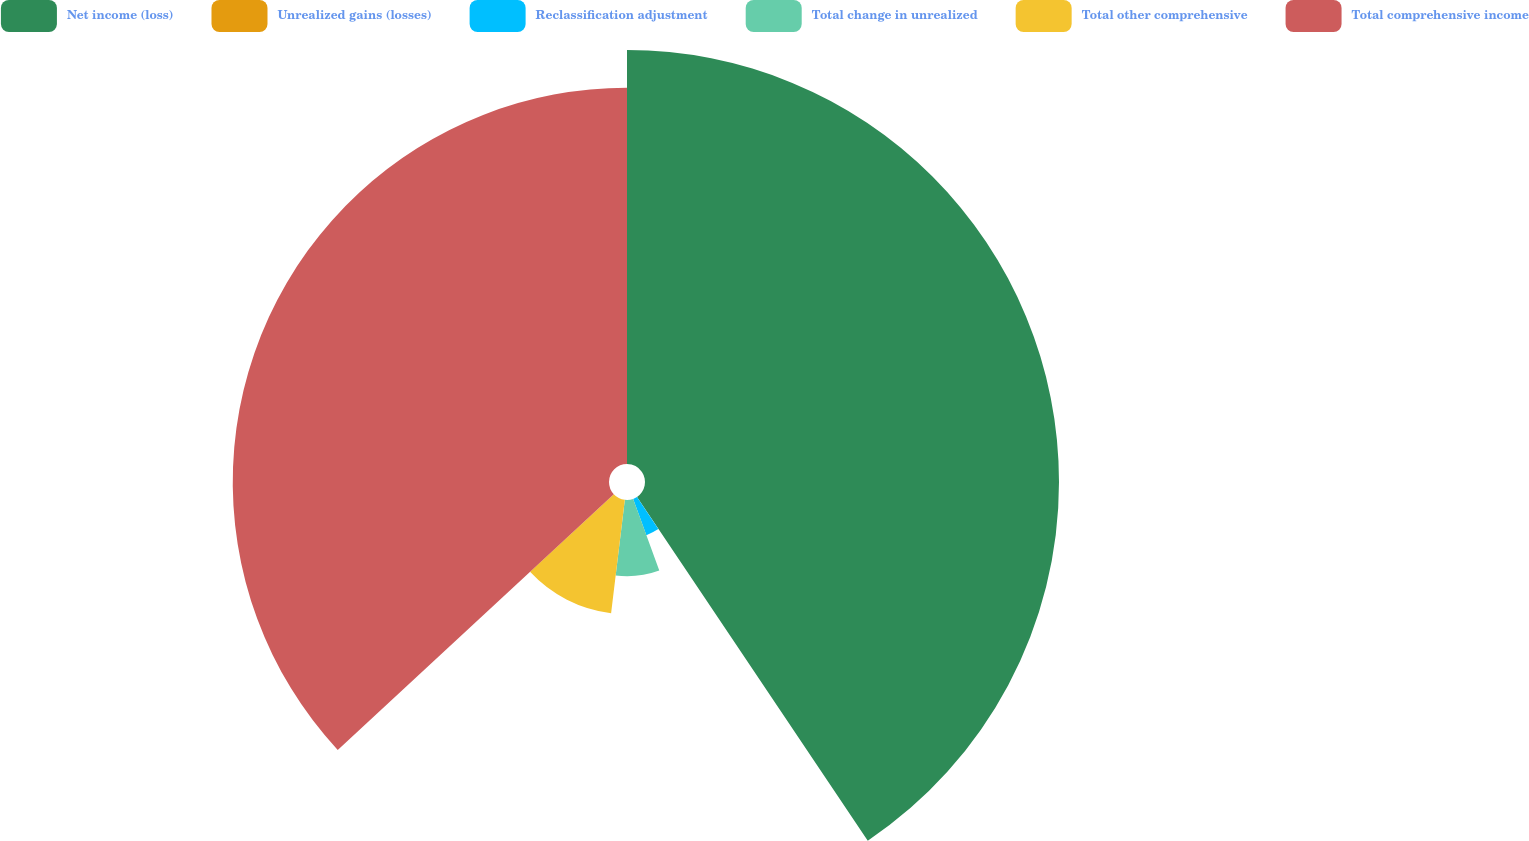Convert chart to OTSL. <chart><loc_0><loc_0><loc_500><loc_500><pie_chart><fcel>Net income (loss)<fcel>Unrealized gains (losses)<fcel>Reclassification adjustment<fcel>Total change in unrealized<fcel>Total other comprehensive<fcel>Total comprehensive income<nl><fcel>40.59%<fcel>0.07%<fcel>3.78%<fcel>7.48%<fcel>11.19%<fcel>36.89%<nl></chart> 